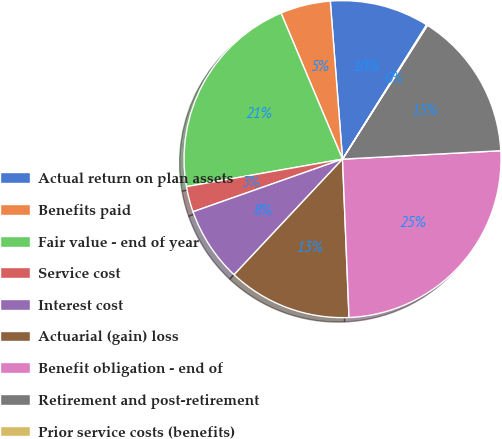<chart> <loc_0><loc_0><loc_500><loc_500><pie_chart><fcel>Actual return on plan assets<fcel>Benefits paid<fcel>Fair value - end of year<fcel>Service cost<fcel>Interest cost<fcel>Actuarial (gain) loss<fcel>Benefit obligation - end of<fcel>Retirement and post-retirement<fcel>Prior service costs (benefits)<nl><fcel>10.13%<fcel>5.11%<fcel>21.43%<fcel>2.61%<fcel>7.62%<fcel>12.64%<fcel>25.19%<fcel>15.15%<fcel>0.1%<nl></chart> 